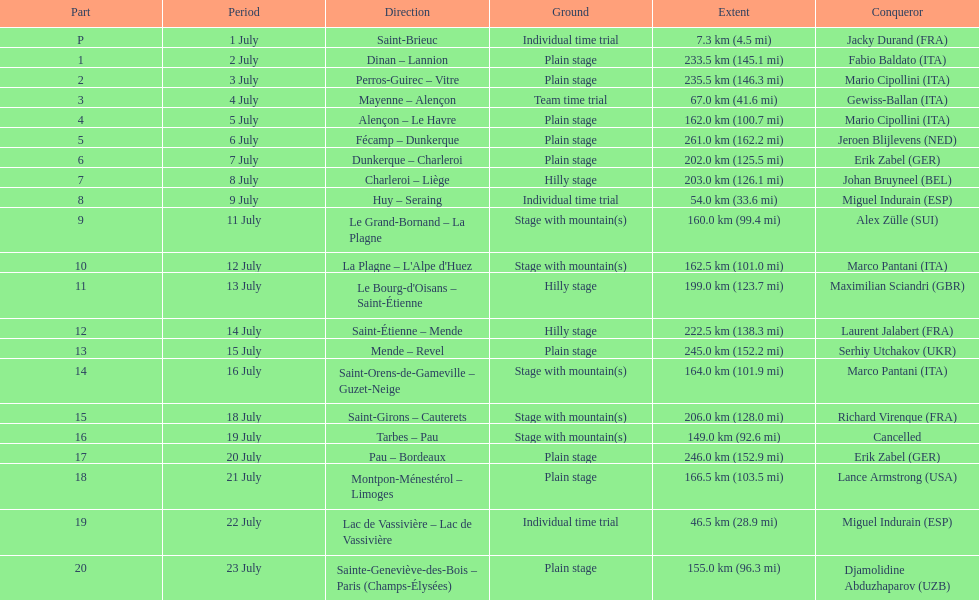Parse the full table. {'header': ['Part', 'Period', 'Direction', 'Ground', 'Extent', 'Conqueror'], 'rows': [['P', '1 July', 'Saint-Brieuc', 'Individual time trial', '7.3\xa0km (4.5\xa0mi)', 'Jacky Durand\xa0(FRA)'], ['1', '2 July', 'Dinan – Lannion', 'Plain stage', '233.5\xa0km (145.1\xa0mi)', 'Fabio Baldato\xa0(ITA)'], ['2', '3 July', 'Perros-Guirec – Vitre', 'Plain stage', '235.5\xa0km (146.3\xa0mi)', 'Mario Cipollini\xa0(ITA)'], ['3', '4 July', 'Mayenne – Alençon', 'Team time trial', '67.0\xa0km (41.6\xa0mi)', 'Gewiss-Ballan\xa0(ITA)'], ['4', '5 July', 'Alençon – Le Havre', 'Plain stage', '162.0\xa0km (100.7\xa0mi)', 'Mario Cipollini\xa0(ITA)'], ['5', '6 July', 'Fécamp – Dunkerque', 'Plain stage', '261.0\xa0km (162.2\xa0mi)', 'Jeroen Blijlevens\xa0(NED)'], ['6', '7 July', 'Dunkerque – Charleroi', 'Plain stage', '202.0\xa0km (125.5\xa0mi)', 'Erik Zabel\xa0(GER)'], ['7', '8 July', 'Charleroi – Liège', 'Hilly stage', '203.0\xa0km (126.1\xa0mi)', 'Johan Bruyneel\xa0(BEL)'], ['8', '9 July', 'Huy – Seraing', 'Individual time trial', '54.0\xa0km (33.6\xa0mi)', 'Miguel Indurain\xa0(ESP)'], ['9', '11 July', 'Le Grand-Bornand – La Plagne', 'Stage with mountain(s)', '160.0\xa0km (99.4\xa0mi)', 'Alex Zülle\xa0(SUI)'], ['10', '12 July', "La Plagne – L'Alpe d'Huez", 'Stage with mountain(s)', '162.5\xa0km (101.0\xa0mi)', 'Marco Pantani\xa0(ITA)'], ['11', '13 July', "Le Bourg-d'Oisans – Saint-Étienne", 'Hilly stage', '199.0\xa0km (123.7\xa0mi)', 'Maximilian Sciandri\xa0(GBR)'], ['12', '14 July', 'Saint-Étienne – Mende', 'Hilly stage', '222.5\xa0km (138.3\xa0mi)', 'Laurent Jalabert\xa0(FRA)'], ['13', '15 July', 'Mende – Revel', 'Plain stage', '245.0\xa0km (152.2\xa0mi)', 'Serhiy Utchakov\xa0(UKR)'], ['14', '16 July', 'Saint-Orens-de-Gameville – Guzet-Neige', 'Stage with mountain(s)', '164.0\xa0km (101.9\xa0mi)', 'Marco Pantani\xa0(ITA)'], ['15', '18 July', 'Saint-Girons – Cauterets', 'Stage with mountain(s)', '206.0\xa0km (128.0\xa0mi)', 'Richard Virenque\xa0(FRA)'], ['16', '19 July', 'Tarbes – Pau', 'Stage with mountain(s)', '149.0\xa0km (92.6\xa0mi)', 'Cancelled'], ['17', '20 July', 'Pau – Bordeaux', 'Plain stage', '246.0\xa0km (152.9\xa0mi)', 'Erik Zabel\xa0(GER)'], ['18', '21 July', 'Montpon-Ménestérol – Limoges', 'Plain stage', '166.5\xa0km (103.5\xa0mi)', 'Lance Armstrong\xa0(USA)'], ['19', '22 July', 'Lac de Vassivière – Lac de Vassivière', 'Individual time trial', '46.5\xa0km (28.9\xa0mi)', 'Miguel Indurain\xa0(ESP)'], ['20', '23 July', 'Sainte-Geneviève-des-Bois – Paris (Champs-Élysées)', 'Plain stage', '155.0\xa0km (96.3\xa0mi)', 'Djamolidine Abduzhaparov\xa0(UZB)']]} Which paths had a minimum distance of 100 km? Dinan - Lannion, Perros-Guirec - Vitre, Alençon - Le Havre, Fécamp - Dunkerque, Dunkerque - Charleroi, Charleroi - Liège, Le Grand-Bornand - La Plagne, La Plagne - L'Alpe d'Huez, Le Bourg-d'Oisans - Saint-Étienne, Saint-Étienne - Mende, Mende - Revel, Saint-Orens-de-Gameville - Guzet-Neige, Saint-Girons - Cauterets, Tarbes - Pau, Pau - Bordeaux, Montpon-Ménestérol - Limoges, Sainte-Geneviève-des-Bois - Paris (Champs-Élysées). 